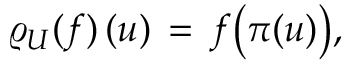<formula> <loc_0><loc_0><loc_500><loc_500>{ \varrho _ { U } ( f ) \, ( u ) \, = \, f \left ( \pi ( u ) \right ) , }</formula> 